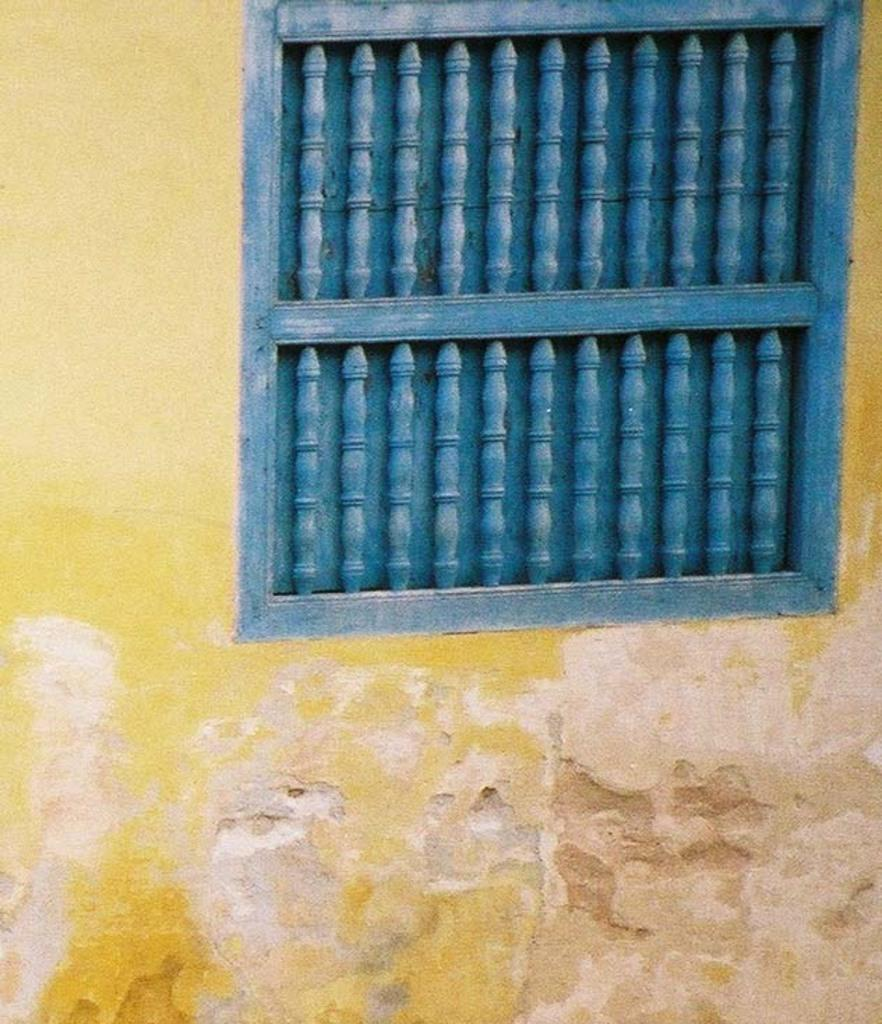What is present in the image? There is a wall in the image. What can be observed about the wall's appearance? The wall has a blue color window. Can you describe the texture of the woman's dress in the image? There is no woman present in the image, so we cannot describe the texture of her dress. 